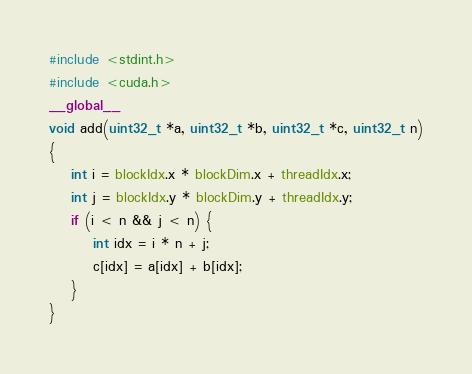<code> <loc_0><loc_0><loc_500><loc_500><_Cuda_>#include <stdint.h>
#include <cuda.h>
__global__
void add(uint32_t *a, uint32_t *b, uint32_t *c, uint32_t n)
{
    int i = blockIdx.x * blockDim.x + threadIdx.x;
    int j = blockIdx.y * blockDim.y + threadIdx.y;
    if (i < n && j < n) {
        int idx = i * n + j;
        c[idx] = a[idx] + b[idx];
    }
}
</code> 